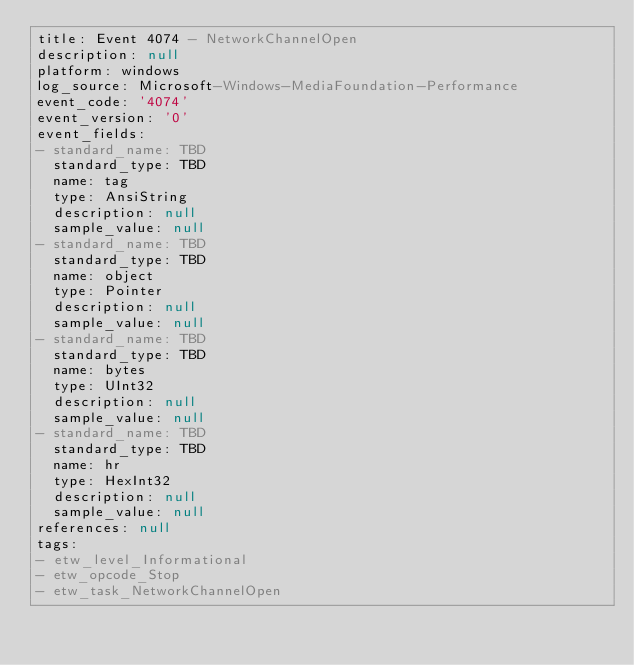<code> <loc_0><loc_0><loc_500><loc_500><_YAML_>title: Event 4074 - NetworkChannelOpen
description: null
platform: windows
log_source: Microsoft-Windows-MediaFoundation-Performance
event_code: '4074'
event_version: '0'
event_fields:
- standard_name: TBD
  standard_type: TBD
  name: tag
  type: AnsiString
  description: null
  sample_value: null
- standard_name: TBD
  standard_type: TBD
  name: object
  type: Pointer
  description: null
  sample_value: null
- standard_name: TBD
  standard_type: TBD
  name: bytes
  type: UInt32
  description: null
  sample_value: null
- standard_name: TBD
  standard_type: TBD
  name: hr
  type: HexInt32
  description: null
  sample_value: null
references: null
tags:
- etw_level_Informational
- etw_opcode_Stop
- etw_task_NetworkChannelOpen
</code> 